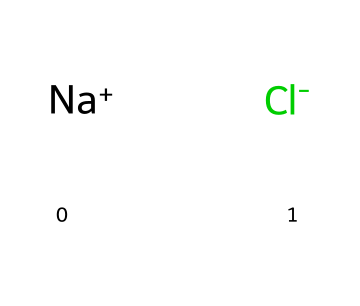what is the net charge of this electrolyte? The SMILES representation shows two ions: sodium (Na+) with a positive charge and chloride (Cl-) with a negative charge. When combined, the positive and negative charges balance each other out, leading to a net charge of zero.
Answer: zero how many different types of atoms are present in this compound? The structure shows one sodium ion and one chloride ion, which means there are two different types of atoms: sodium and chlorine.
Answer: two is this compound an acid or a base? Sodium chloride, depicted here, is classified as a salt. It is neither an acid nor a base but results from the neutralization of an acid and a base.
Answer: salt what role does sodium ion play in electrolyte balance? Sodium ions are crucial for maintaining fluid balance, nerve function, and muscle contractions in the body. Their presence helps regulate osmotic pressure and fluid equilibrium.
Answer: balance what is the most common use of this electrolyte in IV therapies? Sodium chloride is frequently used in IV therapies as a rehydrating solution and to restore electrolyte balance in patients.
Answer: rehydration 